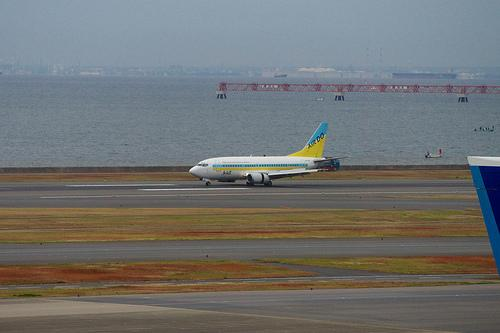What body of water is shown in the image and its characteristics? The ocean water is shown, with ripples and waves, some red structures, and things floating in the water. Mention the key subject of the image and what is it situated on? The key subject is a dual engine airplane with a yellow and blue tail, situated on a runway next to a body of water. Briefly describe the picture’s overall atmosphere. A slightly hazy and foggy day at an airport near the water, with an airplane preparing to take off. What is the primary mode of transportation shown in the image? The primary mode of transportation is an airplane with a light blue and yellow tail wing. Mention a distinguishing feature about the tail of the airplane in the image. The tail of the airplane has blue and yellow paint, with the words "air" and "do" written on it. Write a sentence describing the image's main action. An airplane is on the runway and is about to take off from a foggy airport near the shoreline. Describe the environment and setting of the image. The image shows a foggy grey sky, a runway beside a body of water with red structures, and a city skyline in the distance, along with grass and brown fields. Create a detailed description of the main object in the image. A white airplane with yellow and blue stripes and a dual engine is preparing to take off on a runway near the ocean, featuring a yellow and blue tail fin. List three main objects in the image and their colors. White airplane with yellow and blue stripes, red floating buoy in water, and blue and white structure. Describe the main object's key features and neighboring elements in the image. The airplane features a cockpit window, passenger windows, blue and yellow stripes, propeller, and is next to a runway with red and yellow markings and a body of water. 